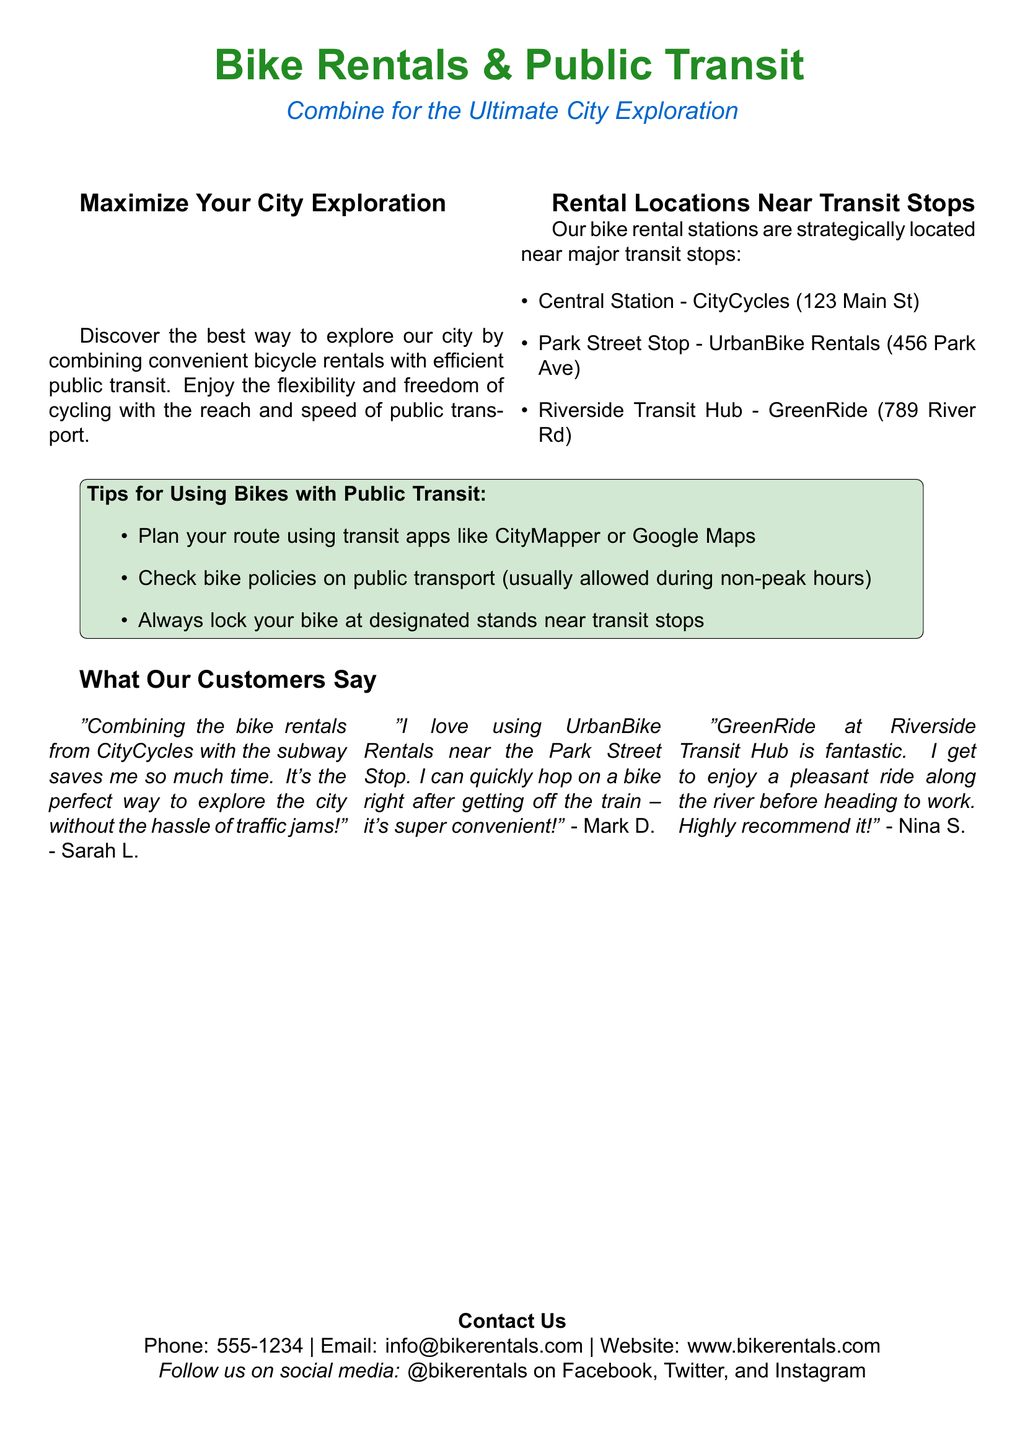What is the title of the flyer? The title of the flyer is prominently displayed at the top of the document and indicates what the flyer is about.
Answer: Bike Rentals & Public Transit How many rental locations are listed? The document mentions specific rental locations, and the total number can be counted from the list.
Answer: Three What is the name of the rental service at Central Station? The name of the rental service is specified near the Central Station in the document.
Answer: CityCycles What tip is provided for using bikes with public transit? The document includes a list of tips for combining bike rentals with public transit, highlighting the most convenient suggestions.
Answer: Plan your route using transit apps Who recommends GreenRide at Riverside Transit Hub? The document includes testimonials from customers, indicating their satisfaction with specific rental services.
Answer: Nina S What is the contact phone number provided? The contact phone number is listed at the bottom of the flyer for inquiries.
Answer: 555-1234 What public transit apps are mentioned? The document specifies which apps are suggested for planning routes with bike rentals and public transit.
Answer: CityMapper, Google Maps What is the main color theme used in the flyer? The general color scheme of the document can be determined from the usage of colors in headings and sections.
Answer: Bike green and transit blue 